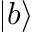Convert formula to latex. <formula><loc_0><loc_0><loc_500><loc_500>| b \rangle</formula> 